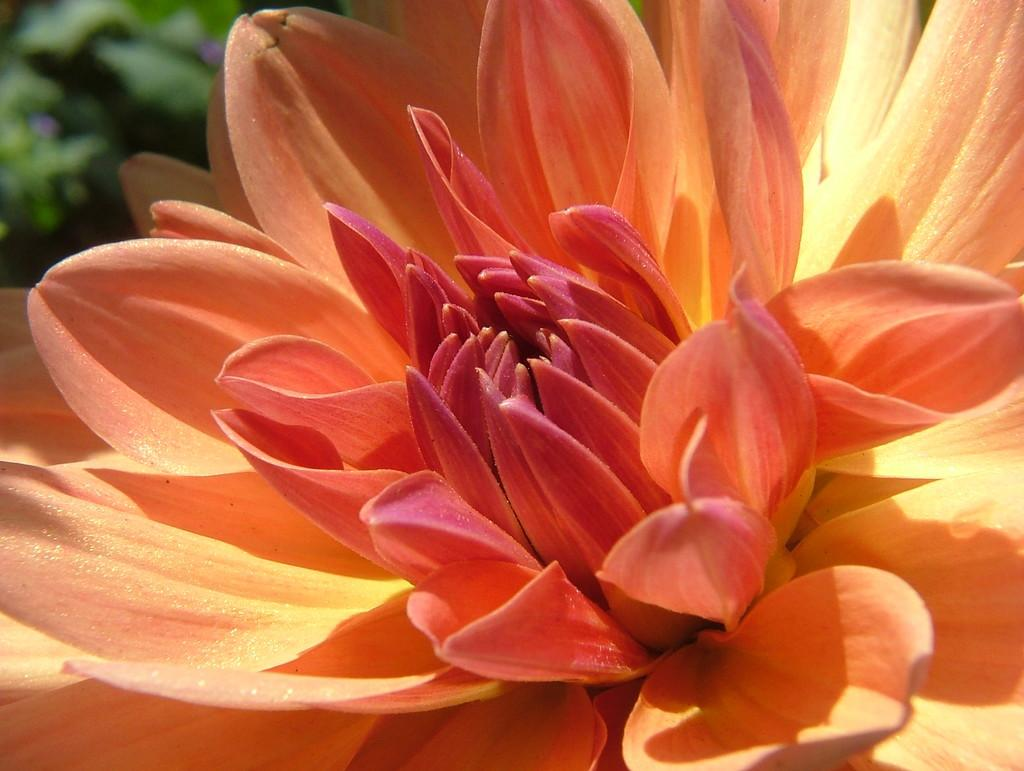What is the main subject of the image? There is a flower in the image. What type of lettuce is being used to polish the car in the image? There is no car or lettuce present in the image; it features a flower. 